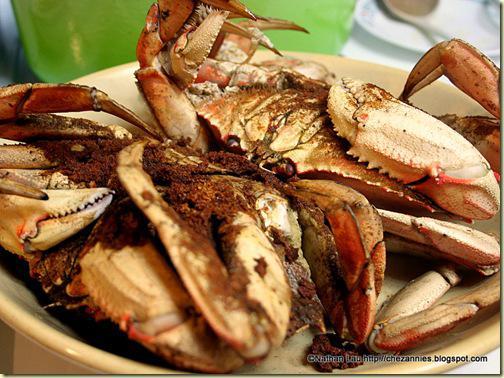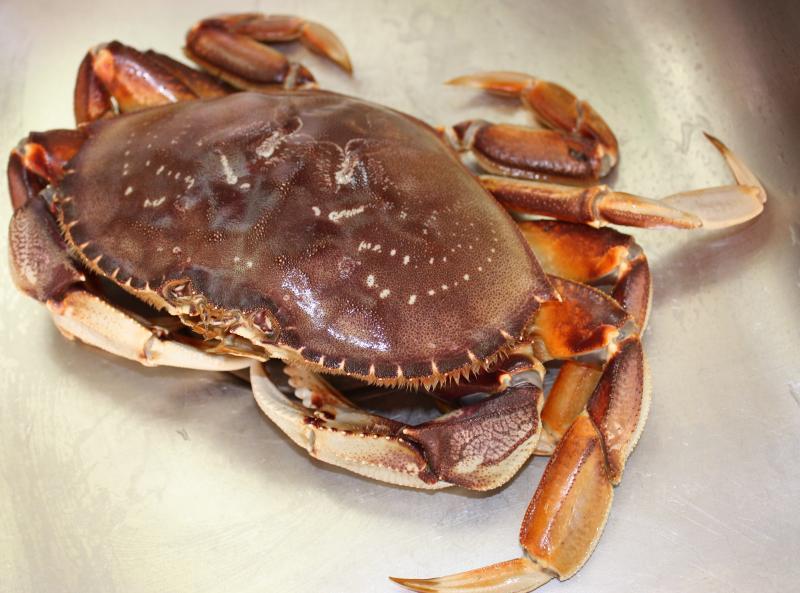The first image is the image on the left, the second image is the image on the right. For the images displayed, is the sentence "Several cooked crabs sit together in at least one of the images." factually correct? Answer yes or no. Yes. The first image is the image on the left, the second image is the image on the right. Analyze the images presented: Is the assertion "There are exactly two crabs." valid? Answer yes or no. No. 